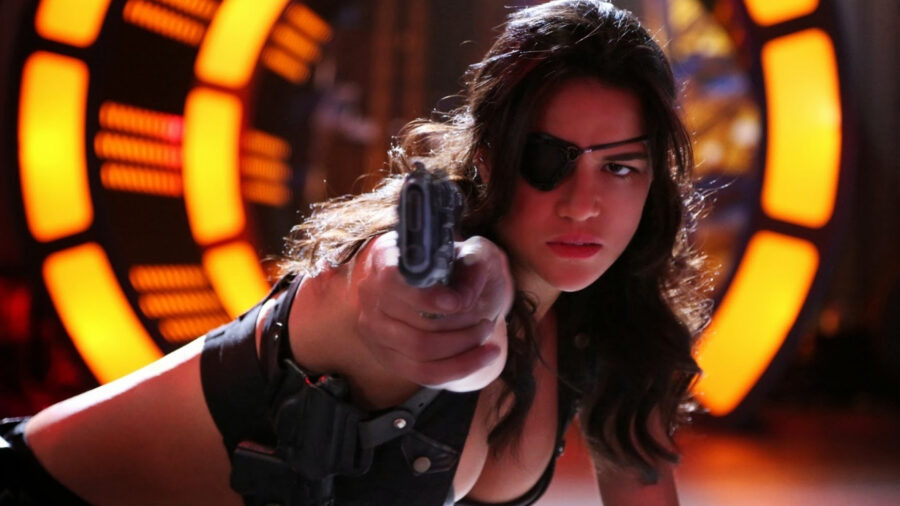This woman looks like she is in a critical moment. Can you describe a short scenario? The woman is in the midst of a high-stakes confrontation inside a high-tech control room. Alarms blare, and flashing lights reflect off her determined face as she points her gun unwaveringly at an unseen adversary. The fate of the mission hangs in the balance, with seconds ticking down on a digital countdown display overhead. All her training and experience come into play as she navigates this critical moment, ready to make the split-second decisions that will determine success or failure.  What could be the reason for such a tense and action-packed atmosphere? The intense and action-packed atmosphere in the image could result from a high-stakes mission where the woman is confronting a significant threat. She could be in the middle of a crucial operation to thwart a powerful enemy's plan, rescue hostages, or retrieve a valuable asset. The vibrant, futuristic background and her serious demeanor suggest the gravity of the situation, with advanced technology indicating that the outcome has far-reaching consequences. This moment might be a pivotal turning point in a battle, where her actions could decide the fate of many lives or the success of a deeply important objective. 